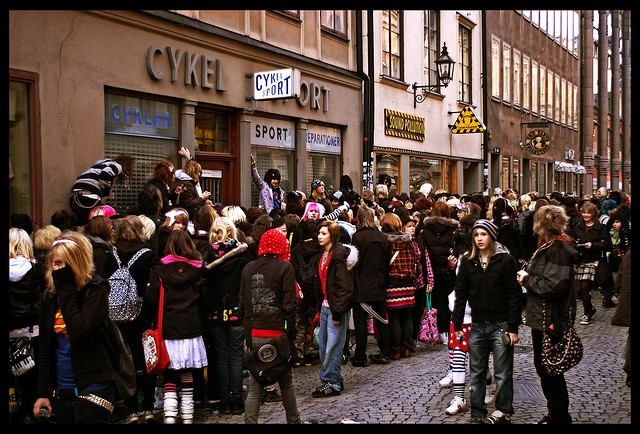Read and extract the text from this image. cyke SPORT SPORT CYKEL CYKEL SPORT 